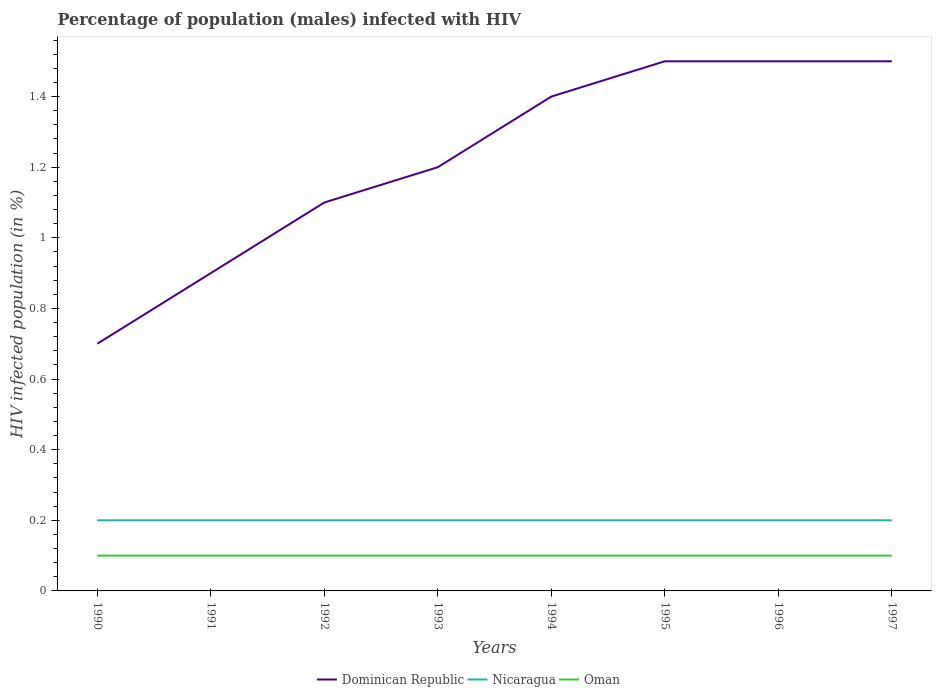Is the number of lines equal to the number of legend labels?
Provide a succinct answer. Yes. Across all years, what is the maximum percentage of HIV infected male population in Oman?
Ensure brevity in your answer.  0.1. In which year was the percentage of HIV infected male population in Dominican Republic maximum?
Keep it short and to the point. 1990. What is the total percentage of HIV infected male population in Oman in the graph?
Provide a succinct answer. 0. Is the percentage of HIV infected male population in Dominican Republic strictly greater than the percentage of HIV infected male population in Oman over the years?
Ensure brevity in your answer.  No. How many lines are there?
Your answer should be compact. 3. What is the difference between two consecutive major ticks on the Y-axis?
Your answer should be compact. 0.2. Does the graph contain grids?
Keep it short and to the point. No. Where does the legend appear in the graph?
Provide a succinct answer. Bottom center. How are the legend labels stacked?
Offer a very short reply. Horizontal. What is the title of the graph?
Ensure brevity in your answer.  Percentage of population (males) infected with HIV. Does "Japan" appear as one of the legend labels in the graph?
Your answer should be compact. No. What is the label or title of the X-axis?
Your answer should be very brief. Years. What is the label or title of the Y-axis?
Offer a very short reply. HIV infected population (in %). What is the HIV infected population (in %) of Nicaragua in 1990?
Offer a terse response. 0.2. What is the HIV infected population (in %) in Nicaragua in 1991?
Offer a very short reply. 0.2. What is the HIV infected population (in %) in Dominican Republic in 1992?
Make the answer very short. 1.1. What is the HIV infected population (in %) of Nicaragua in 1992?
Offer a terse response. 0.2. What is the HIV infected population (in %) of Nicaragua in 1993?
Ensure brevity in your answer.  0.2. What is the HIV infected population (in %) in Oman in 1993?
Offer a very short reply. 0.1. What is the HIV infected population (in %) of Dominican Republic in 1994?
Give a very brief answer. 1.4. What is the HIV infected population (in %) of Nicaragua in 1995?
Keep it short and to the point. 0.2. What is the HIV infected population (in %) of Dominican Republic in 1996?
Give a very brief answer. 1.5. What is the HIV infected population (in %) of Nicaragua in 1996?
Your answer should be very brief. 0.2. What is the HIV infected population (in %) of Oman in 1996?
Your answer should be very brief. 0.1. What is the HIV infected population (in %) of Dominican Republic in 1997?
Your answer should be very brief. 1.5. What is the HIV infected population (in %) of Nicaragua in 1997?
Make the answer very short. 0.2. What is the HIV infected population (in %) of Oman in 1997?
Offer a terse response. 0.1. Across all years, what is the maximum HIV infected population (in %) in Dominican Republic?
Provide a short and direct response. 1.5. Across all years, what is the maximum HIV infected population (in %) in Nicaragua?
Provide a short and direct response. 0.2. Across all years, what is the maximum HIV infected population (in %) of Oman?
Provide a short and direct response. 0.1. Across all years, what is the minimum HIV infected population (in %) in Nicaragua?
Your answer should be compact. 0.2. Across all years, what is the minimum HIV infected population (in %) in Oman?
Make the answer very short. 0.1. What is the total HIV infected population (in %) of Dominican Republic in the graph?
Your response must be concise. 9.8. What is the difference between the HIV infected population (in %) in Nicaragua in 1990 and that in 1991?
Offer a terse response. 0. What is the difference between the HIV infected population (in %) in Dominican Republic in 1990 and that in 1992?
Your response must be concise. -0.4. What is the difference between the HIV infected population (in %) of Nicaragua in 1990 and that in 1992?
Offer a terse response. 0. What is the difference between the HIV infected population (in %) of Nicaragua in 1990 and that in 1993?
Ensure brevity in your answer.  0. What is the difference between the HIV infected population (in %) of Oman in 1990 and that in 1993?
Offer a very short reply. 0. What is the difference between the HIV infected population (in %) in Nicaragua in 1990 and that in 1994?
Your response must be concise. 0. What is the difference between the HIV infected population (in %) of Oman in 1990 and that in 1994?
Give a very brief answer. 0. What is the difference between the HIV infected population (in %) of Dominican Republic in 1990 and that in 1995?
Provide a short and direct response. -0.8. What is the difference between the HIV infected population (in %) in Nicaragua in 1990 and that in 1995?
Your answer should be very brief. 0. What is the difference between the HIV infected population (in %) in Oman in 1990 and that in 1997?
Make the answer very short. 0. What is the difference between the HIV infected population (in %) of Nicaragua in 1991 and that in 1992?
Your answer should be very brief. 0. What is the difference between the HIV infected population (in %) of Oman in 1991 and that in 1992?
Ensure brevity in your answer.  0. What is the difference between the HIV infected population (in %) of Oman in 1991 and that in 1993?
Provide a succinct answer. 0. What is the difference between the HIV infected population (in %) of Oman in 1991 and that in 1994?
Keep it short and to the point. 0. What is the difference between the HIV infected population (in %) of Dominican Republic in 1991 and that in 1995?
Ensure brevity in your answer.  -0.6. What is the difference between the HIV infected population (in %) of Nicaragua in 1991 and that in 1995?
Offer a terse response. 0. What is the difference between the HIV infected population (in %) in Oman in 1991 and that in 1995?
Keep it short and to the point. 0. What is the difference between the HIV infected population (in %) in Dominican Republic in 1991 and that in 1996?
Your answer should be very brief. -0.6. What is the difference between the HIV infected population (in %) in Oman in 1991 and that in 1997?
Offer a very short reply. 0. What is the difference between the HIV infected population (in %) of Dominican Republic in 1992 and that in 1993?
Offer a very short reply. -0.1. What is the difference between the HIV infected population (in %) of Nicaragua in 1992 and that in 1993?
Ensure brevity in your answer.  0. What is the difference between the HIV infected population (in %) in Dominican Republic in 1992 and that in 1994?
Give a very brief answer. -0.3. What is the difference between the HIV infected population (in %) of Nicaragua in 1992 and that in 1994?
Give a very brief answer. 0. What is the difference between the HIV infected population (in %) in Dominican Republic in 1992 and that in 1995?
Ensure brevity in your answer.  -0.4. What is the difference between the HIV infected population (in %) of Nicaragua in 1992 and that in 1995?
Offer a very short reply. 0. What is the difference between the HIV infected population (in %) in Oman in 1992 and that in 1995?
Keep it short and to the point. 0. What is the difference between the HIV infected population (in %) of Dominican Republic in 1992 and that in 1996?
Provide a succinct answer. -0.4. What is the difference between the HIV infected population (in %) in Nicaragua in 1992 and that in 1996?
Your answer should be very brief. 0. What is the difference between the HIV infected population (in %) in Dominican Republic in 1992 and that in 1997?
Provide a short and direct response. -0.4. What is the difference between the HIV infected population (in %) in Nicaragua in 1992 and that in 1997?
Your answer should be very brief. 0. What is the difference between the HIV infected population (in %) in Oman in 1993 and that in 1994?
Your answer should be compact. 0. What is the difference between the HIV infected population (in %) in Dominican Republic in 1993 and that in 1995?
Offer a very short reply. -0.3. What is the difference between the HIV infected population (in %) of Nicaragua in 1993 and that in 1995?
Offer a terse response. 0. What is the difference between the HIV infected population (in %) in Oman in 1993 and that in 1995?
Your answer should be compact. 0. What is the difference between the HIV infected population (in %) in Dominican Republic in 1993 and that in 1996?
Your answer should be compact. -0.3. What is the difference between the HIV infected population (in %) of Nicaragua in 1994 and that in 1995?
Make the answer very short. 0. What is the difference between the HIV infected population (in %) of Oman in 1994 and that in 1995?
Keep it short and to the point. 0. What is the difference between the HIV infected population (in %) of Dominican Republic in 1994 and that in 1996?
Your answer should be very brief. -0.1. What is the difference between the HIV infected population (in %) in Nicaragua in 1994 and that in 1996?
Ensure brevity in your answer.  0. What is the difference between the HIV infected population (in %) of Dominican Republic in 1994 and that in 1997?
Your answer should be compact. -0.1. What is the difference between the HIV infected population (in %) of Nicaragua in 1994 and that in 1997?
Make the answer very short. 0. What is the difference between the HIV infected population (in %) in Oman in 1994 and that in 1997?
Your response must be concise. 0. What is the difference between the HIV infected population (in %) of Dominican Republic in 1995 and that in 1996?
Ensure brevity in your answer.  0. What is the difference between the HIV infected population (in %) in Nicaragua in 1995 and that in 1996?
Make the answer very short. 0. What is the difference between the HIV infected population (in %) in Oman in 1995 and that in 1996?
Make the answer very short. 0. What is the difference between the HIV infected population (in %) of Nicaragua in 1995 and that in 1997?
Your answer should be compact. 0. What is the difference between the HIV infected population (in %) of Nicaragua in 1996 and that in 1997?
Your answer should be compact. 0. What is the difference between the HIV infected population (in %) of Dominican Republic in 1990 and the HIV infected population (in %) of Oman in 1991?
Offer a very short reply. 0.6. What is the difference between the HIV infected population (in %) of Nicaragua in 1990 and the HIV infected population (in %) of Oman in 1991?
Your answer should be very brief. 0.1. What is the difference between the HIV infected population (in %) in Dominican Republic in 1990 and the HIV infected population (in %) in Oman in 1993?
Provide a short and direct response. 0.6. What is the difference between the HIV infected population (in %) of Nicaragua in 1990 and the HIV infected population (in %) of Oman in 1993?
Make the answer very short. 0.1. What is the difference between the HIV infected population (in %) of Dominican Republic in 1990 and the HIV infected population (in %) of Oman in 1994?
Ensure brevity in your answer.  0.6. What is the difference between the HIV infected population (in %) in Dominican Republic in 1990 and the HIV infected population (in %) in Nicaragua in 1995?
Provide a succinct answer. 0.5. What is the difference between the HIV infected population (in %) in Nicaragua in 1990 and the HIV infected population (in %) in Oman in 1995?
Make the answer very short. 0.1. What is the difference between the HIV infected population (in %) in Nicaragua in 1990 and the HIV infected population (in %) in Oman in 1996?
Your answer should be compact. 0.1. What is the difference between the HIV infected population (in %) in Dominican Republic in 1990 and the HIV infected population (in %) in Oman in 1997?
Offer a very short reply. 0.6. What is the difference between the HIV infected population (in %) in Nicaragua in 1990 and the HIV infected population (in %) in Oman in 1997?
Offer a terse response. 0.1. What is the difference between the HIV infected population (in %) in Dominican Republic in 1991 and the HIV infected population (in %) in Nicaragua in 1992?
Offer a very short reply. 0.7. What is the difference between the HIV infected population (in %) in Nicaragua in 1991 and the HIV infected population (in %) in Oman in 1992?
Ensure brevity in your answer.  0.1. What is the difference between the HIV infected population (in %) in Nicaragua in 1991 and the HIV infected population (in %) in Oman in 1993?
Keep it short and to the point. 0.1. What is the difference between the HIV infected population (in %) in Dominican Republic in 1991 and the HIV infected population (in %) in Oman in 1994?
Provide a succinct answer. 0.8. What is the difference between the HIV infected population (in %) of Nicaragua in 1991 and the HIV infected population (in %) of Oman in 1994?
Keep it short and to the point. 0.1. What is the difference between the HIV infected population (in %) of Dominican Republic in 1991 and the HIV infected population (in %) of Oman in 1995?
Keep it short and to the point. 0.8. What is the difference between the HIV infected population (in %) of Nicaragua in 1991 and the HIV infected population (in %) of Oman in 1995?
Make the answer very short. 0.1. What is the difference between the HIV infected population (in %) of Dominican Republic in 1991 and the HIV infected population (in %) of Nicaragua in 1996?
Keep it short and to the point. 0.7. What is the difference between the HIV infected population (in %) in Nicaragua in 1991 and the HIV infected population (in %) in Oman in 1996?
Keep it short and to the point. 0.1. What is the difference between the HIV infected population (in %) in Dominican Republic in 1991 and the HIV infected population (in %) in Nicaragua in 1997?
Offer a terse response. 0.7. What is the difference between the HIV infected population (in %) in Nicaragua in 1991 and the HIV infected population (in %) in Oman in 1997?
Your answer should be very brief. 0.1. What is the difference between the HIV infected population (in %) in Dominican Republic in 1992 and the HIV infected population (in %) in Nicaragua in 1993?
Offer a very short reply. 0.9. What is the difference between the HIV infected population (in %) in Dominican Republic in 1992 and the HIV infected population (in %) in Oman in 1993?
Offer a terse response. 1. What is the difference between the HIV infected population (in %) in Dominican Republic in 1992 and the HIV infected population (in %) in Nicaragua in 1994?
Your response must be concise. 0.9. What is the difference between the HIV infected population (in %) of Dominican Republic in 1992 and the HIV infected population (in %) of Oman in 1994?
Provide a succinct answer. 1. What is the difference between the HIV infected population (in %) of Nicaragua in 1992 and the HIV infected population (in %) of Oman in 1994?
Provide a succinct answer. 0.1. What is the difference between the HIV infected population (in %) in Nicaragua in 1992 and the HIV infected population (in %) in Oman in 1995?
Give a very brief answer. 0.1. What is the difference between the HIV infected population (in %) of Dominican Republic in 1992 and the HIV infected population (in %) of Oman in 1996?
Provide a short and direct response. 1. What is the difference between the HIV infected population (in %) in Nicaragua in 1992 and the HIV infected population (in %) in Oman in 1996?
Provide a succinct answer. 0.1. What is the difference between the HIV infected population (in %) of Dominican Republic in 1992 and the HIV infected population (in %) of Oman in 1997?
Keep it short and to the point. 1. What is the difference between the HIV infected population (in %) in Nicaragua in 1992 and the HIV infected population (in %) in Oman in 1997?
Provide a succinct answer. 0.1. What is the difference between the HIV infected population (in %) in Nicaragua in 1993 and the HIV infected population (in %) in Oman in 1995?
Give a very brief answer. 0.1. What is the difference between the HIV infected population (in %) of Dominican Republic in 1993 and the HIV infected population (in %) of Nicaragua in 1996?
Give a very brief answer. 1. What is the difference between the HIV infected population (in %) of Nicaragua in 1993 and the HIV infected population (in %) of Oman in 1997?
Provide a short and direct response. 0.1. What is the difference between the HIV infected population (in %) of Dominican Republic in 1994 and the HIV infected population (in %) of Oman in 1995?
Your answer should be very brief. 1.3. What is the difference between the HIV infected population (in %) in Dominican Republic in 1994 and the HIV infected population (in %) in Nicaragua in 1996?
Provide a succinct answer. 1.2. What is the difference between the HIV infected population (in %) of Dominican Republic in 1994 and the HIV infected population (in %) of Oman in 1996?
Provide a short and direct response. 1.3. What is the difference between the HIV infected population (in %) in Dominican Republic in 1994 and the HIV infected population (in %) in Nicaragua in 1997?
Your answer should be compact. 1.2. What is the difference between the HIV infected population (in %) in Dominican Republic in 1994 and the HIV infected population (in %) in Oman in 1997?
Provide a succinct answer. 1.3. What is the difference between the HIV infected population (in %) of Dominican Republic in 1995 and the HIV infected population (in %) of Oman in 1996?
Provide a short and direct response. 1.4. What is the difference between the HIV infected population (in %) of Nicaragua in 1995 and the HIV infected population (in %) of Oman in 1996?
Make the answer very short. 0.1. What is the difference between the HIV infected population (in %) in Dominican Republic in 1995 and the HIV infected population (in %) in Nicaragua in 1997?
Ensure brevity in your answer.  1.3. What is the difference between the HIV infected population (in %) of Dominican Republic in 1995 and the HIV infected population (in %) of Oman in 1997?
Your answer should be compact. 1.4. What is the difference between the HIV infected population (in %) of Nicaragua in 1995 and the HIV infected population (in %) of Oman in 1997?
Offer a terse response. 0.1. What is the difference between the HIV infected population (in %) in Dominican Republic in 1996 and the HIV infected population (in %) in Nicaragua in 1997?
Provide a short and direct response. 1.3. What is the difference between the HIV infected population (in %) of Dominican Republic in 1996 and the HIV infected population (in %) of Oman in 1997?
Offer a very short reply. 1.4. What is the difference between the HIV infected population (in %) of Nicaragua in 1996 and the HIV infected population (in %) of Oman in 1997?
Keep it short and to the point. 0.1. What is the average HIV infected population (in %) of Dominican Republic per year?
Provide a short and direct response. 1.23. What is the average HIV infected population (in %) of Nicaragua per year?
Give a very brief answer. 0.2. What is the average HIV infected population (in %) in Oman per year?
Make the answer very short. 0.1. In the year 1990, what is the difference between the HIV infected population (in %) in Dominican Republic and HIV infected population (in %) in Nicaragua?
Provide a short and direct response. 0.5. In the year 1992, what is the difference between the HIV infected population (in %) in Dominican Republic and HIV infected population (in %) in Nicaragua?
Keep it short and to the point. 0.9. In the year 1992, what is the difference between the HIV infected population (in %) in Nicaragua and HIV infected population (in %) in Oman?
Your response must be concise. 0.1. In the year 1993, what is the difference between the HIV infected population (in %) of Dominican Republic and HIV infected population (in %) of Oman?
Offer a very short reply. 1.1. In the year 1994, what is the difference between the HIV infected population (in %) in Dominican Republic and HIV infected population (in %) in Oman?
Provide a short and direct response. 1.3. In the year 1994, what is the difference between the HIV infected population (in %) of Nicaragua and HIV infected population (in %) of Oman?
Keep it short and to the point. 0.1. In the year 1995, what is the difference between the HIV infected population (in %) in Dominican Republic and HIV infected population (in %) in Nicaragua?
Keep it short and to the point. 1.3. In the year 1995, what is the difference between the HIV infected population (in %) in Dominican Republic and HIV infected population (in %) in Oman?
Provide a succinct answer. 1.4. In the year 1995, what is the difference between the HIV infected population (in %) of Nicaragua and HIV infected population (in %) of Oman?
Your answer should be very brief. 0.1. In the year 1996, what is the difference between the HIV infected population (in %) in Dominican Republic and HIV infected population (in %) in Oman?
Provide a succinct answer. 1.4. In the year 1997, what is the difference between the HIV infected population (in %) in Dominican Republic and HIV infected population (in %) in Nicaragua?
Your response must be concise. 1.3. In the year 1997, what is the difference between the HIV infected population (in %) of Dominican Republic and HIV infected population (in %) of Oman?
Provide a succinct answer. 1.4. What is the ratio of the HIV infected population (in %) of Dominican Republic in 1990 to that in 1992?
Make the answer very short. 0.64. What is the ratio of the HIV infected population (in %) in Nicaragua in 1990 to that in 1992?
Provide a short and direct response. 1. What is the ratio of the HIV infected population (in %) in Dominican Republic in 1990 to that in 1993?
Provide a succinct answer. 0.58. What is the ratio of the HIV infected population (in %) in Dominican Republic in 1990 to that in 1994?
Give a very brief answer. 0.5. What is the ratio of the HIV infected population (in %) in Nicaragua in 1990 to that in 1994?
Provide a short and direct response. 1. What is the ratio of the HIV infected population (in %) in Dominican Republic in 1990 to that in 1995?
Provide a succinct answer. 0.47. What is the ratio of the HIV infected population (in %) in Nicaragua in 1990 to that in 1995?
Your response must be concise. 1. What is the ratio of the HIV infected population (in %) in Dominican Republic in 1990 to that in 1996?
Give a very brief answer. 0.47. What is the ratio of the HIV infected population (in %) in Nicaragua in 1990 to that in 1996?
Keep it short and to the point. 1. What is the ratio of the HIV infected population (in %) of Oman in 1990 to that in 1996?
Your answer should be compact. 1. What is the ratio of the HIV infected population (in %) in Dominican Republic in 1990 to that in 1997?
Ensure brevity in your answer.  0.47. What is the ratio of the HIV infected population (in %) in Nicaragua in 1990 to that in 1997?
Keep it short and to the point. 1. What is the ratio of the HIV infected population (in %) of Dominican Republic in 1991 to that in 1992?
Make the answer very short. 0.82. What is the ratio of the HIV infected population (in %) of Oman in 1991 to that in 1992?
Make the answer very short. 1. What is the ratio of the HIV infected population (in %) of Nicaragua in 1991 to that in 1993?
Your answer should be compact. 1. What is the ratio of the HIV infected population (in %) in Dominican Republic in 1991 to that in 1994?
Your answer should be compact. 0.64. What is the ratio of the HIV infected population (in %) of Oman in 1991 to that in 1994?
Offer a very short reply. 1. What is the ratio of the HIV infected population (in %) of Nicaragua in 1991 to that in 1995?
Offer a very short reply. 1. What is the ratio of the HIV infected population (in %) in Dominican Republic in 1991 to that in 1996?
Your answer should be compact. 0.6. What is the ratio of the HIV infected population (in %) in Oman in 1991 to that in 1996?
Provide a succinct answer. 1. What is the ratio of the HIV infected population (in %) of Dominican Republic in 1991 to that in 1997?
Your answer should be very brief. 0.6. What is the ratio of the HIV infected population (in %) of Dominican Republic in 1992 to that in 1993?
Give a very brief answer. 0.92. What is the ratio of the HIV infected population (in %) of Oman in 1992 to that in 1993?
Provide a succinct answer. 1. What is the ratio of the HIV infected population (in %) of Dominican Republic in 1992 to that in 1994?
Offer a very short reply. 0.79. What is the ratio of the HIV infected population (in %) of Dominican Republic in 1992 to that in 1995?
Offer a very short reply. 0.73. What is the ratio of the HIV infected population (in %) in Oman in 1992 to that in 1995?
Keep it short and to the point. 1. What is the ratio of the HIV infected population (in %) of Dominican Republic in 1992 to that in 1996?
Give a very brief answer. 0.73. What is the ratio of the HIV infected population (in %) of Oman in 1992 to that in 1996?
Give a very brief answer. 1. What is the ratio of the HIV infected population (in %) of Dominican Republic in 1992 to that in 1997?
Provide a short and direct response. 0.73. What is the ratio of the HIV infected population (in %) of Oman in 1992 to that in 1997?
Your response must be concise. 1. What is the ratio of the HIV infected population (in %) in Dominican Republic in 1993 to that in 1994?
Your response must be concise. 0.86. What is the ratio of the HIV infected population (in %) of Nicaragua in 1993 to that in 1994?
Your answer should be compact. 1. What is the ratio of the HIV infected population (in %) in Oman in 1993 to that in 1994?
Your answer should be very brief. 1. What is the ratio of the HIV infected population (in %) in Dominican Republic in 1993 to that in 1995?
Your answer should be compact. 0.8. What is the ratio of the HIV infected population (in %) in Nicaragua in 1993 to that in 1995?
Your response must be concise. 1. What is the ratio of the HIV infected population (in %) in Oman in 1993 to that in 1996?
Your answer should be very brief. 1. What is the ratio of the HIV infected population (in %) of Dominican Republic in 1993 to that in 1997?
Provide a short and direct response. 0.8. What is the ratio of the HIV infected population (in %) of Dominican Republic in 1994 to that in 1995?
Your answer should be compact. 0.93. What is the ratio of the HIV infected population (in %) of Nicaragua in 1994 to that in 1995?
Keep it short and to the point. 1. What is the ratio of the HIV infected population (in %) in Dominican Republic in 1994 to that in 1996?
Your answer should be very brief. 0.93. What is the ratio of the HIV infected population (in %) in Nicaragua in 1994 to that in 1996?
Make the answer very short. 1. What is the ratio of the HIV infected population (in %) in Dominican Republic in 1994 to that in 1997?
Provide a succinct answer. 0.93. What is the ratio of the HIV infected population (in %) in Nicaragua in 1994 to that in 1997?
Your answer should be very brief. 1. What is the ratio of the HIV infected population (in %) in Nicaragua in 1995 to that in 1996?
Make the answer very short. 1. What is the ratio of the HIV infected population (in %) in Nicaragua in 1995 to that in 1997?
Provide a short and direct response. 1. What is the ratio of the HIV infected population (in %) of Dominican Republic in 1996 to that in 1997?
Make the answer very short. 1. What is the ratio of the HIV infected population (in %) of Nicaragua in 1996 to that in 1997?
Your response must be concise. 1. What is the ratio of the HIV infected population (in %) of Oman in 1996 to that in 1997?
Give a very brief answer. 1. What is the difference between the highest and the second highest HIV infected population (in %) of Dominican Republic?
Your response must be concise. 0. What is the difference between the highest and the lowest HIV infected population (in %) in Dominican Republic?
Keep it short and to the point. 0.8. What is the difference between the highest and the lowest HIV infected population (in %) in Nicaragua?
Keep it short and to the point. 0. 